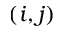<formula> <loc_0><loc_0><loc_500><loc_500>( i , j )</formula> 